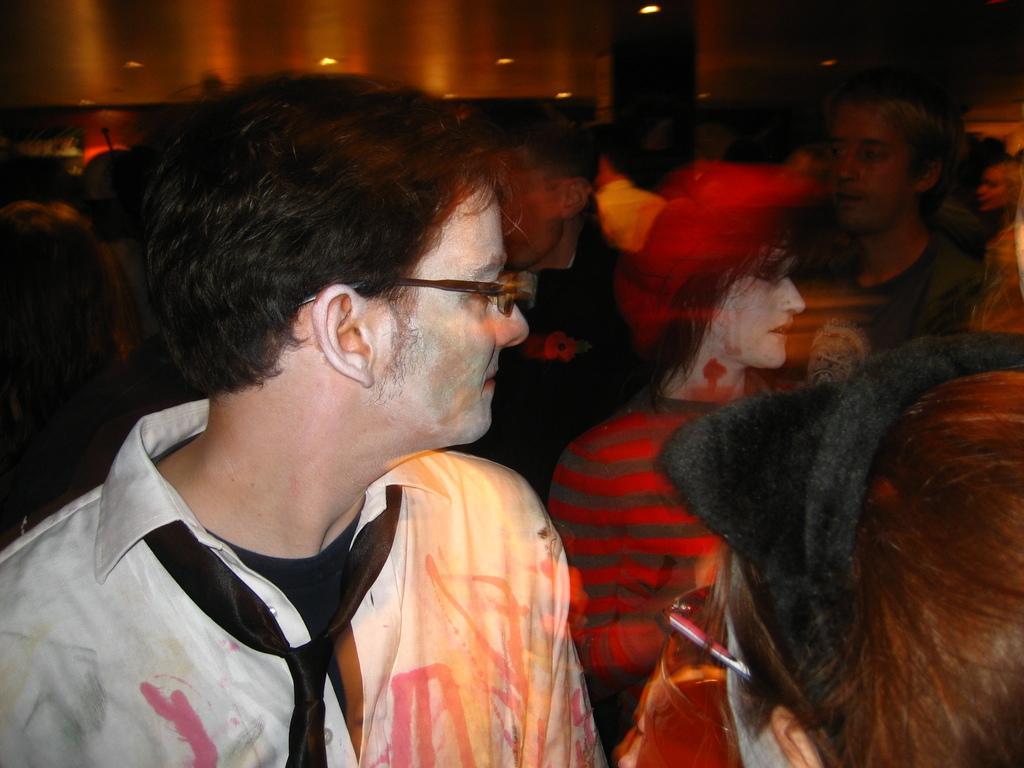Can you describe this image briefly? In this picture I can see a person with spectacles, there are group of people, there are lights, and there is blur background. 